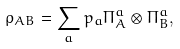<formula> <loc_0><loc_0><loc_500><loc_500>\rho _ { A B } = \sum _ { a } p _ { a } \Pi _ { A } ^ { a } \otimes \Pi _ { B } ^ { a } ,</formula> 